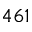<formula> <loc_0><loc_0><loc_500><loc_500>4 6 1</formula> 